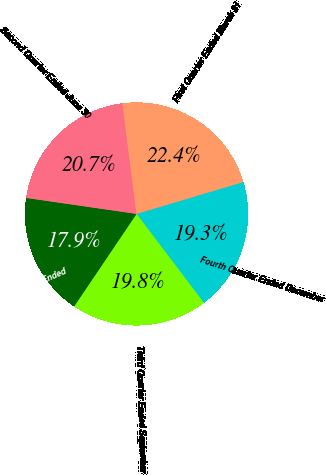<chart> <loc_0><loc_0><loc_500><loc_500><pie_chart><fcel>Fourth Quarter Ended December<fcel>Third Quarter Ended September<fcel>2016 Fourth Quarter Ended<fcel>Second Quarter Ended June 30<fcel>First Quarter Ended March 31<nl><fcel>19.31%<fcel>19.76%<fcel>17.85%<fcel>20.68%<fcel>22.4%<nl></chart> 